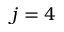Convert formula to latex. <formula><loc_0><loc_0><loc_500><loc_500>j = 4</formula> 